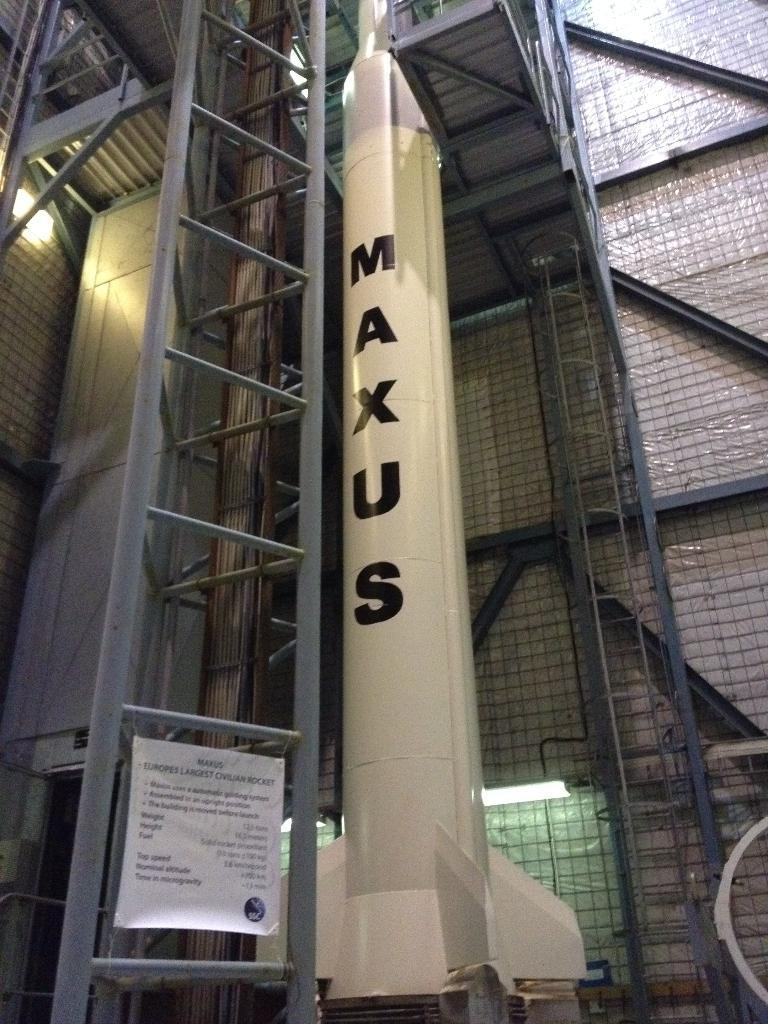What is the main subject of the image? There is a rocket in the image. Where was the image likely taken? The image was likely taken inside a building. What other object can be seen in the image? There is a ladder in the image. What is attached to the ladder? There is a banner tied to the ladder. What disease is being treated in the image? There is no indication of a disease or treatment in the image; it features a rocket, a ladder, and a banner. 